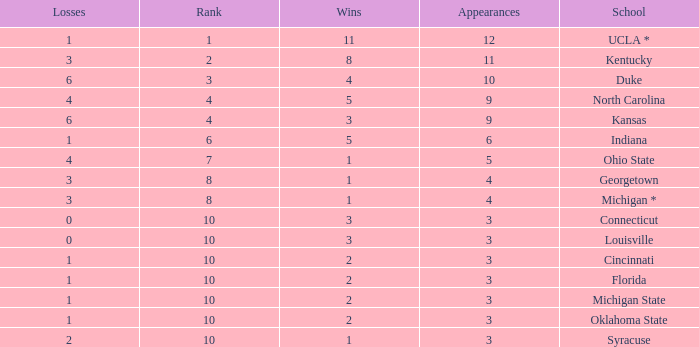Tell me the sum of losses for wins less than 2 and rank of 10 with appearances larger than 3 None. 